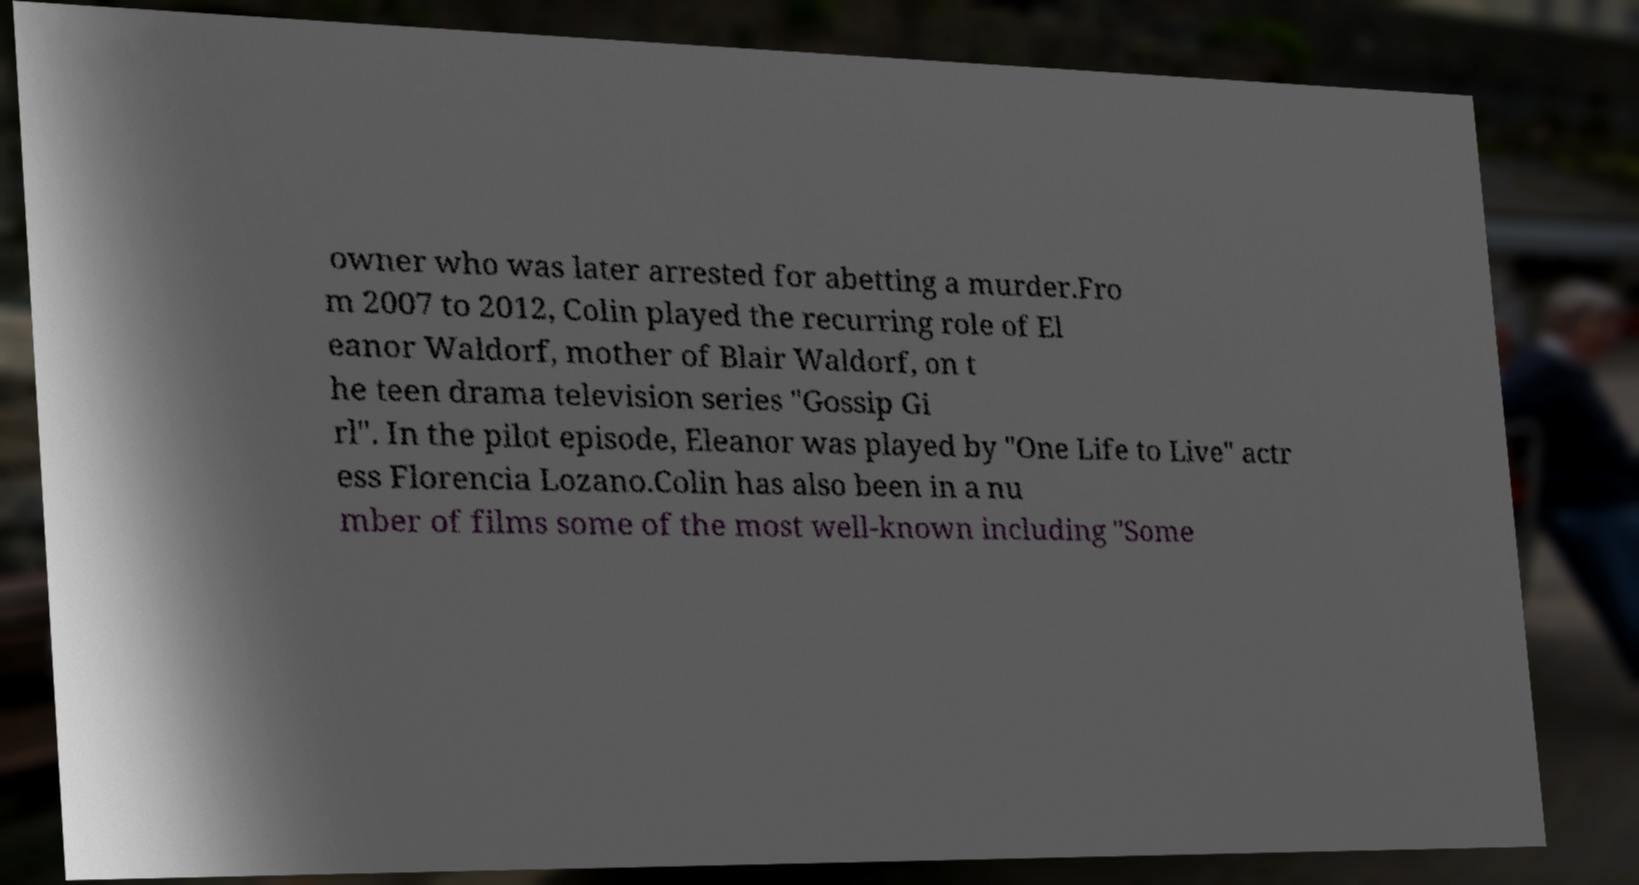Please identify and transcribe the text found in this image. owner who was later arrested for abetting a murder.Fro m 2007 to 2012, Colin played the recurring role of El eanor Waldorf, mother of Blair Waldorf, on t he teen drama television series "Gossip Gi rl". In the pilot episode, Eleanor was played by "One Life to Live" actr ess Florencia Lozano.Colin has also been in a nu mber of films some of the most well-known including "Some 